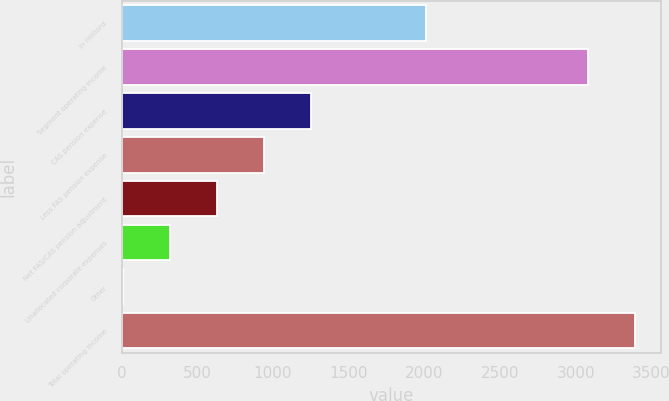<chart> <loc_0><loc_0><loc_500><loc_500><bar_chart><fcel>in millions<fcel>Segment operating income<fcel>CAS pension expense<fcel>Less FAS pension expense<fcel>Net FAS/CAS pension adjustment<fcel>Unallocated corporate expenses<fcel>Other<fcel>Total operating income<nl><fcel>2013<fcel>3080<fcel>1252.8<fcel>941.1<fcel>629.4<fcel>317.7<fcel>6<fcel>3391.7<nl></chart> 